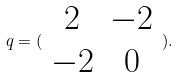<formula> <loc_0><loc_0><loc_500><loc_500>q = ( \begin{array} { c c } 2 & - 2 \\ - 2 & 0 \end{array} ) .</formula> 